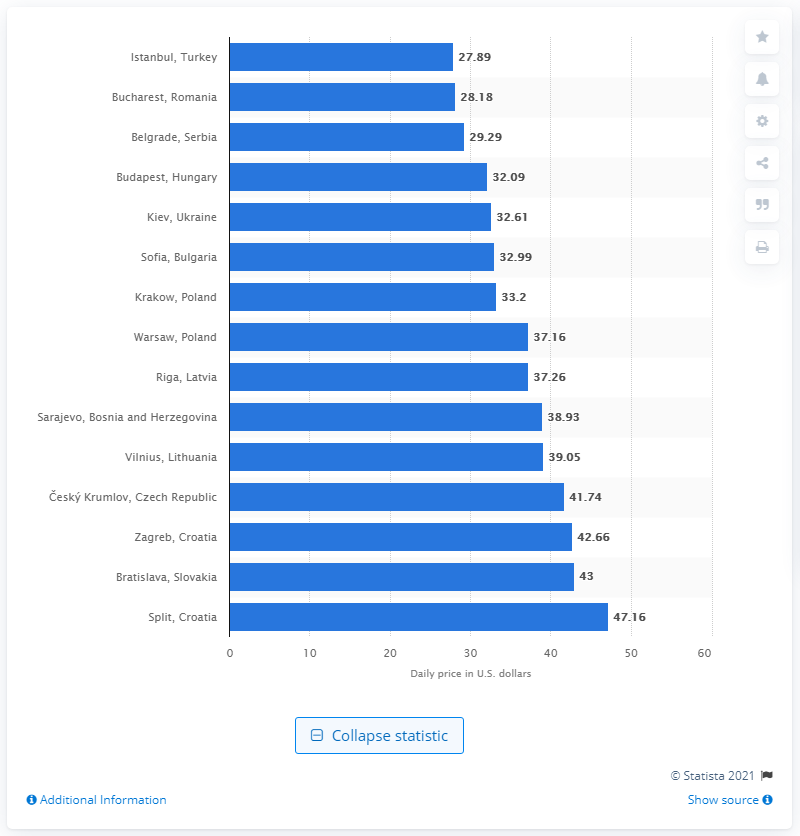Draw attention to some important aspects in this diagram. In a typical day, the average cost of staying in a cheap hostel, eating budget meals, using public transportation, and using a small entertainment allowance was around 27.89 USD. 